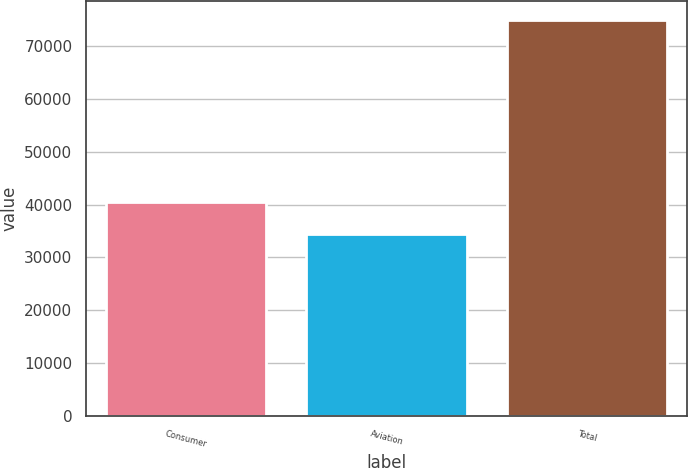Convert chart to OTSL. <chart><loc_0><loc_0><loc_500><loc_500><bar_chart><fcel>Consumer<fcel>Aviation<fcel>Total<nl><fcel>40476<fcel>34403<fcel>74879<nl></chart> 